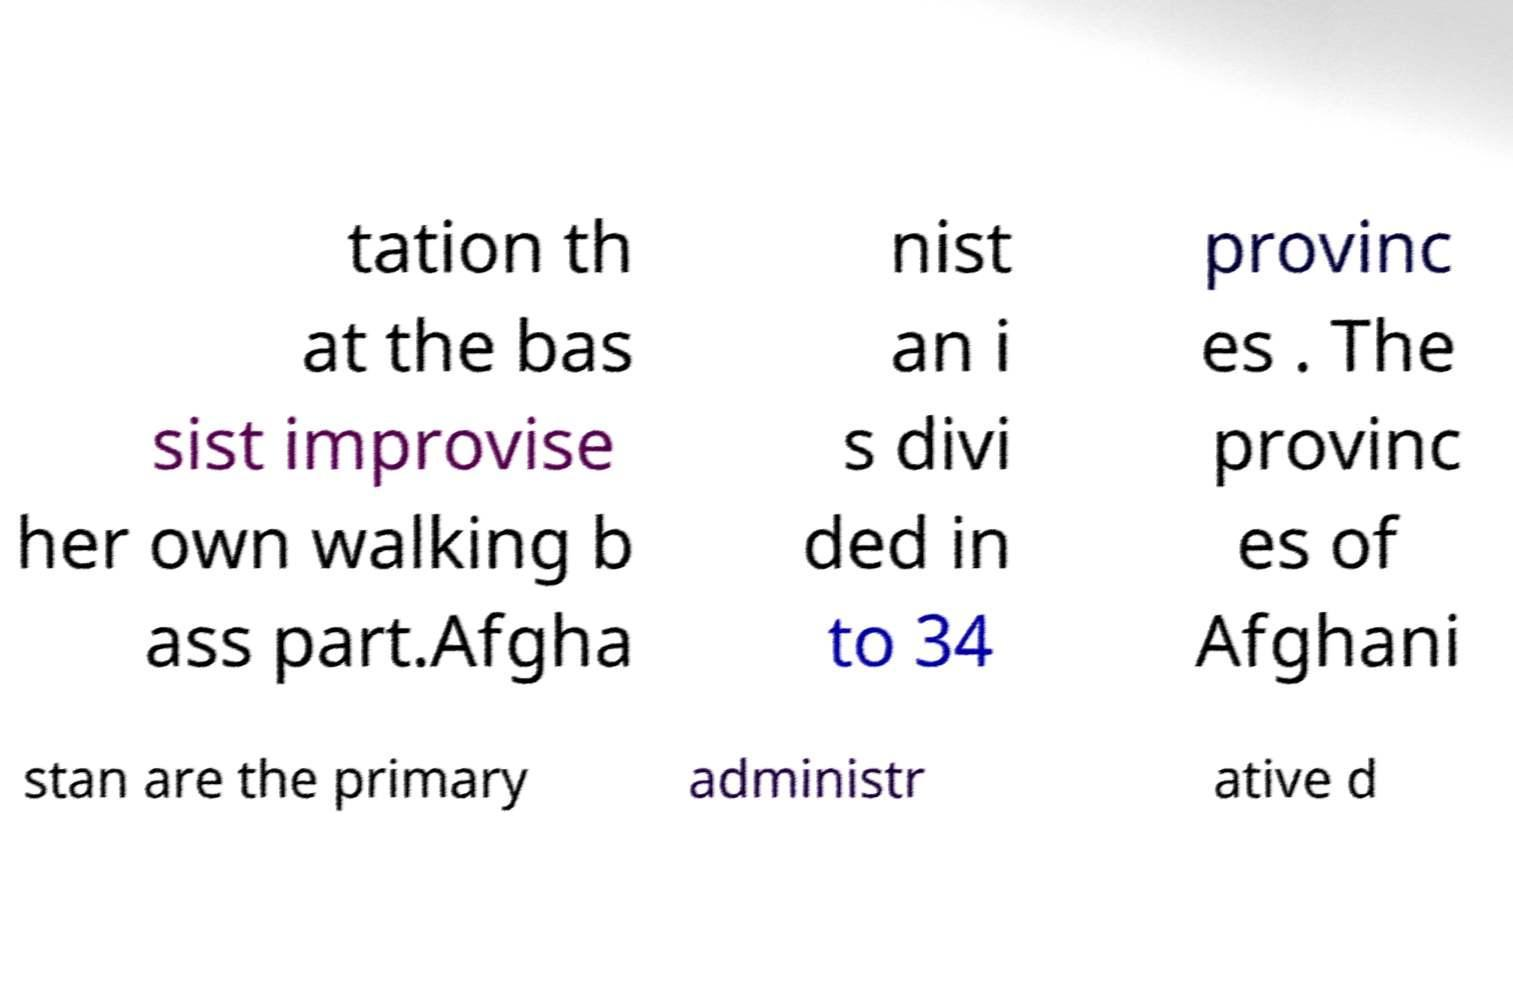I need the written content from this picture converted into text. Can you do that? tation th at the bas sist improvise her own walking b ass part.Afgha nist an i s divi ded in to 34 provinc es . The provinc es of Afghani stan are the primary administr ative d 